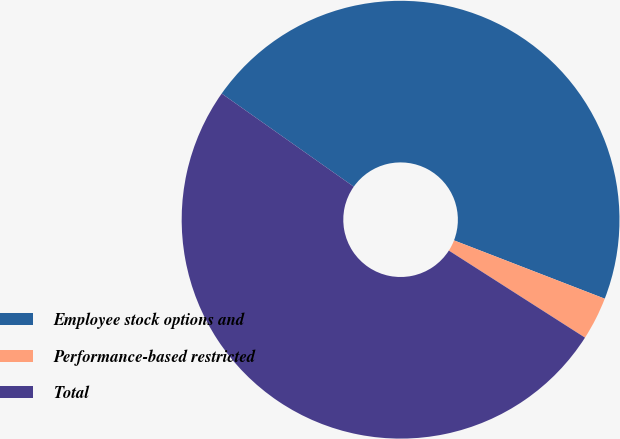Convert chart. <chart><loc_0><loc_0><loc_500><loc_500><pie_chart><fcel>Employee stock options and<fcel>Performance-based restricted<fcel>Total<nl><fcel>46.1%<fcel>3.18%<fcel>50.72%<nl></chart> 